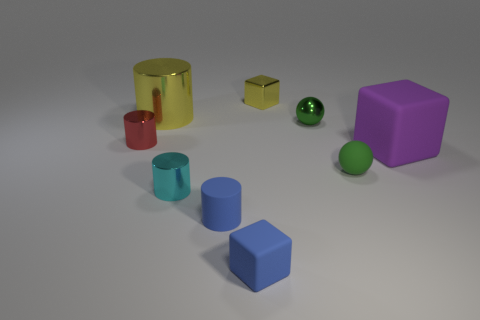Is the number of tiny green objects on the right side of the metal block greater than the number of tiny yellow metal things?
Make the answer very short. Yes. There is a small green object behind the small red cylinder; what number of green objects are on the right side of it?
Give a very brief answer. 1. Are there fewer small yellow shiny cubes behind the tiny yellow thing than gray cylinders?
Offer a terse response. No. There is a tiny rubber thing that is left of the small cube in front of the small green metallic sphere; are there any big yellow metallic things in front of it?
Your answer should be very brief. No. Are the yellow cube and the large object to the left of the big cube made of the same material?
Give a very brief answer. Yes. What color is the tiny metallic object behind the cylinder that is behind the small red metal cylinder?
Your answer should be compact. Yellow. Are there any other rubber spheres of the same color as the small rubber ball?
Make the answer very short. No. What is the size of the ball that is behind the tiny cylinder that is left of the yellow metal object in front of the yellow cube?
Provide a succinct answer. Small. Is the shape of the small red metal object the same as the yellow thing to the left of the tiny cyan shiny cylinder?
Make the answer very short. Yes. How many other objects are there of the same size as the purple matte block?
Give a very brief answer. 1. 